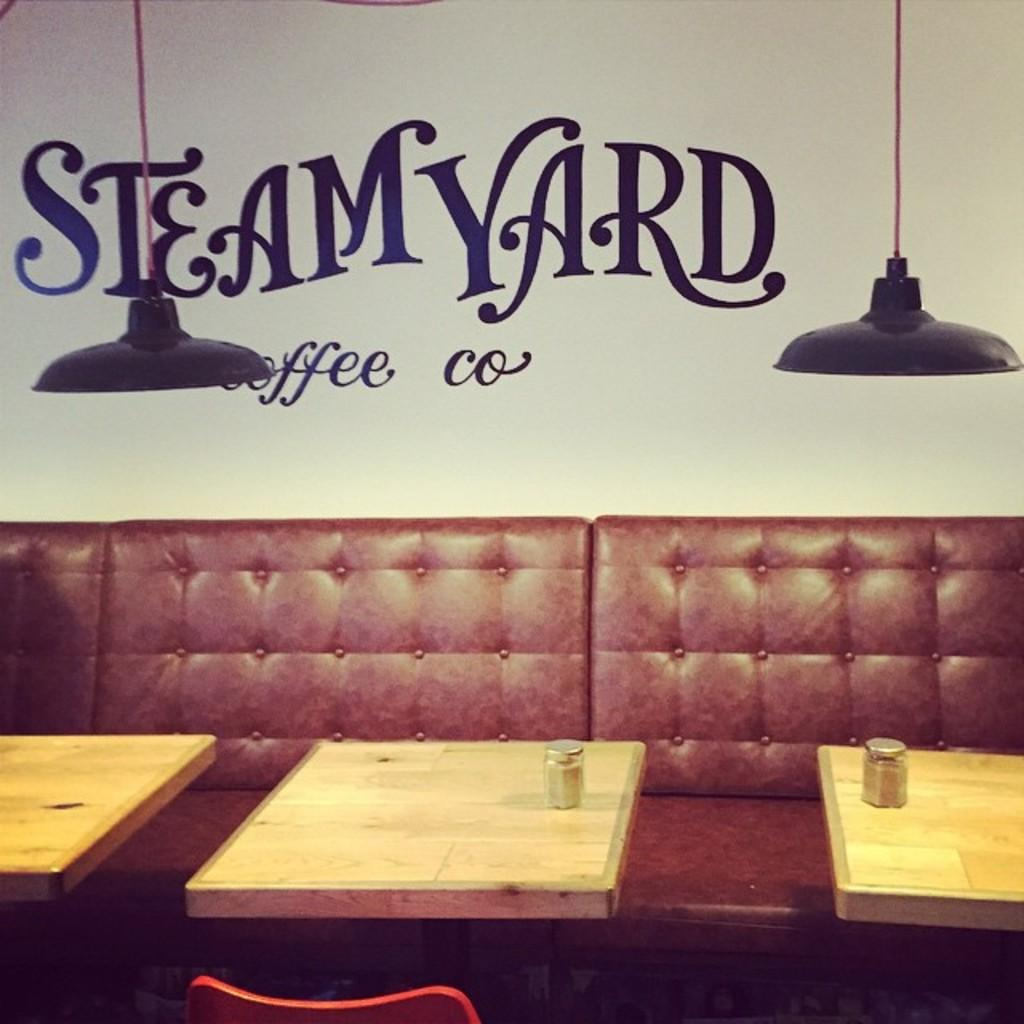What type of furniture is in the image? There is a sofa and a chair in the image. What is located in front of the sofa? There are tables in front of the sofa. What can be found on the tables? There are jars on the table. What can be seen in the background of the image? There is a wall, lights, and a poster in the background of the image. What type of pig is depicted on the poster in the background of the image? There is no pig depicted on the poster in the background of the image. What type of silk material is used to cover the chair in the image? The chair in the image does not appear to be covered in silk or any other specific material. 